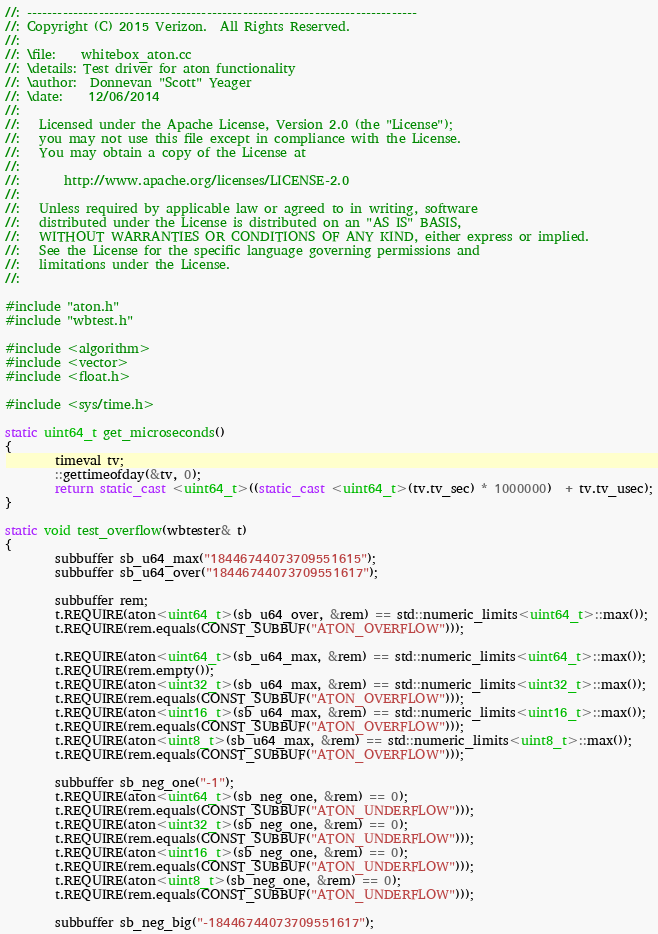<code> <loc_0><loc_0><loc_500><loc_500><_C++_>//: ----------------------------------------------------------------------------
//: Copyright (C) 2015 Verizon.  All Rights Reserved.
//:
//: \file:    whitebox_aton.cc
//: \details: Test driver for aton functionality
//: \author:  Donnevan "Scott" Yeager
//: \date:    12/06/2014
//:
//:   Licensed under the Apache License, Version 2.0 (the "License");
//:   you may not use this file except in compliance with the License.
//:   You may obtain a copy of the License at
//:
//:       http://www.apache.org/licenses/LICENSE-2.0
//:
//:   Unless required by applicable law or agreed to in writing, software
//:   distributed under the License is distributed on an "AS IS" BASIS,
//:   WITHOUT WARRANTIES OR CONDITIONS OF ANY KIND, either express or implied.
//:   See the License for the specific language governing permissions and
//:   limitations under the License.
//:

#include "aton.h"
#include "wbtest.h"

#include <algorithm>
#include <vector>
#include <float.h>

#include <sys/time.h>

static uint64_t get_microseconds()
{
        timeval tv;
        ::gettimeofday(&tv, 0);
        return static_cast <uint64_t>((static_cast <uint64_t>(tv.tv_sec) * 1000000)  + tv.tv_usec);
}

static void test_overflow(wbtester& t)
{
        subbuffer sb_u64_max("18446744073709551615");
        subbuffer sb_u64_over("18446744073709551617");

        subbuffer rem;
        t.REQUIRE(aton<uint64_t>(sb_u64_over, &rem) == std::numeric_limits<uint64_t>::max());
        t.REQUIRE(rem.equals(CONST_SUBBUF("ATON_OVERFLOW")));

        t.REQUIRE(aton<uint64_t>(sb_u64_max, &rem) == std::numeric_limits<uint64_t>::max());
        t.REQUIRE(rem.empty());
        t.REQUIRE(aton<uint32_t>(sb_u64_max, &rem) == std::numeric_limits<uint32_t>::max());
        t.REQUIRE(rem.equals(CONST_SUBBUF("ATON_OVERFLOW")));
        t.REQUIRE(aton<uint16_t>(sb_u64_max, &rem) == std::numeric_limits<uint16_t>::max());
        t.REQUIRE(rem.equals(CONST_SUBBUF("ATON_OVERFLOW")));
        t.REQUIRE(aton<uint8_t>(sb_u64_max, &rem) == std::numeric_limits<uint8_t>::max());
        t.REQUIRE(rem.equals(CONST_SUBBUF("ATON_OVERFLOW")));

        subbuffer sb_neg_one("-1");
        t.REQUIRE(aton<uint64_t>(sb_neg_one, &rem) == 0);
        t.REQUIRE(rem.equals(CONST_SUBBUF("ATON_UNDERFLOW")));
        t.REQUIRE(aton<uint32_t>(sb_neg_one, &rem) == 0);
        t.REQUIRE(rem.equals(CONST_SUBBUF("ATON_UNDERFLOW")));
        t.REQUIRE(aton<uint16_t>(sb_neg_one, &rem) == 0);
        t.REQUIRE(rem.equals(CONST_SUBBUF("ATON_UNDERFLOW")));
        t.REQUIRE(aton<uint8_t>(sb_neg_one, &rem) == 0);
        t.REQUIRE(rem.equals(CONST_SUBBUF("ATON_UNDERFLOW")));

        subbuffer sb_neg_big("-18446744073709551617");</code> 